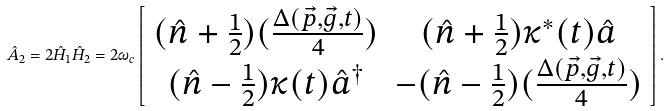Convert formula to latex. <formula><loc_0><loc_0><loc_500><loc_500>\hat { A } _ { 2 } = 2 \hat { H } _ { 1 } \hat { H } _ { 2 } = 2 \omega _ { c } \left [ \begin{array} { c c c c } ( \hat { n } + \frac { 1 } { 2 } ) ( \frac { \Delta ( \vec { p } , \vec { g } , t ) } { 4 } ) & ( \hat { n } + \frac { 1 } { 2 } ) \kappa ^ { * } ( t ) \hat { a } \\ ( \hat { n } - \frac { 1 } { 2 } ) \kappa ( t ) \hat { a } ^ { \dagger } & - ( \hat { n } - \frac { 1 } { 2 } ) ( \frac { \Delta ( \vec { p } , \vec { g } , t ) } { 4 } ) \\ \end{array} \right ] .</formula> 